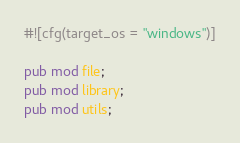<code> <loc_0><loc_0><loc_500><loc_500><_Rust_>#![cfg(target_os = "windows")]

pub mod file;
pub mod library;
pub mod utils;
</code> 